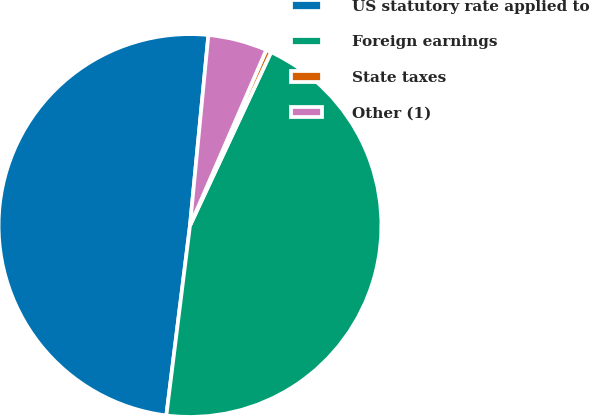Convert chart to OTSL. <chart><loc_0><loc_0><loc_500><loc_500><pie_chart><fcel>US statutory rate applied to<fcel>Foreign earnings<fcel>State taxes<fcel>Other (1)<nl><fcel>49.56%<fcel>45.01%<fcel>0.44%<fcel>4.99%<nl></chart> 